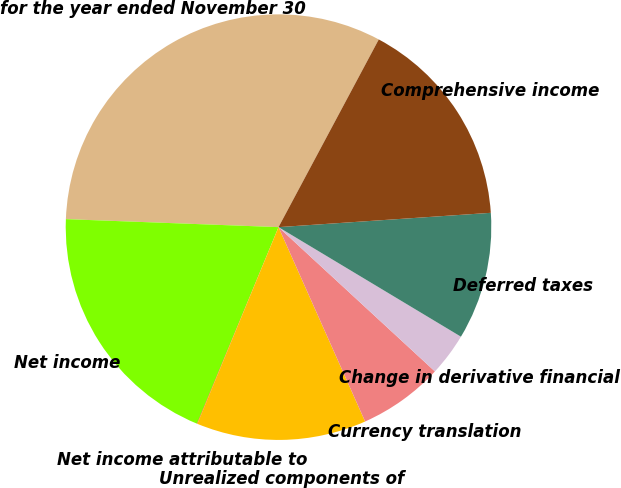Convert chart to OTSL. <chart><loc_0><loc_0><loc_500><loc_500><pie_chart><fcel>for the year ended November 30<fcel>Net income<fcel>Net income attributable to<fcel>Unrealized components of<fcel>Currency translation<fcel>Change in derivative financial<fcel>Deferred taxes<fcel>Comprehensive income<nl><fcel>32.21%<fcel>19.34%<fcel>0.03%<fcel>12.9%<fcel>6.47%<fcel>3.25%<fcel>9.68%<fcel>16.12%<nl></chart> 